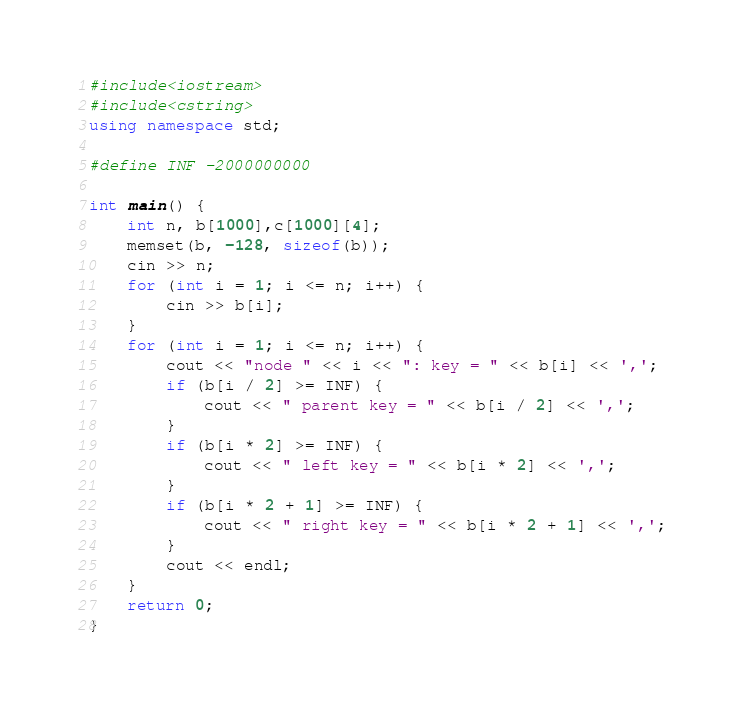<code> <loc_0><loc_0><loc_500><loc_500><_C++_>#include<iostream>
#include<cstring>
using namespace std;

#define INF -2000000000

int main() {
	int n, b[1000],c[1000][4];
	memset(b, -128, sizeof(b));
	cin >> n;
	for (int i = 1; i <= n; i++) {
		cin >> b[i];
	}
	for (int i = 1; i <= n; i++) {
		cout << "node " << i << ": key = " << b[i] << ',';
		if (b[i / 2] >= INF) {
			cout << " parent key = " << b[i / 2] << ',';
		}
		if (b[i * 2] >= INF) {
			cout << " left key = " << b[i * 2] << ',';
		}
		if (b[i * 2 + 1] >= INF) {
			cout << " right key = " << b[i * 2 + 1] << ',';
		}
		cout << endl;
	}
	return 0;
}</code> 